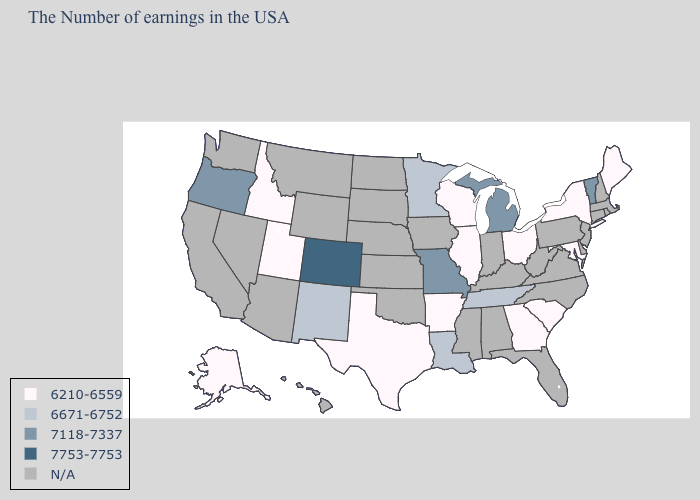Name the states that have a value in the range 7118-7337?
Quick response, please. Vermont, Michigan, Missouri, Oregon. What is the value of South Carolina?
Write a very short answer. 6210-6559. Name the states that have a value in the range 6210-6559?
Write a very short answer. Maine, New York, Maryland, South Carolina, Ohio, Georgia, Wisconsin, Illinois, Arkansas, Texas, Utah, Idaho, Alaska. What is the lowest value in the Northeast?
Quick response, please. 6210-6559. What is the highest value in the South ?
Be succinct. 6671-6752. Does the first symbol in the legend represent the smallest category?
Answer briefly. Yes. Is the legend a continuous bar?
Concise answer only. No. What is the lowest value in the MidWest?
Give a very brief answer. 6210-6559. Among the states that border Nebraska , does Missouri have the highest value?
Concise answer only. No. Does Michigan have the lowest value in the USA?
Write a very short answer. No. Does Colorado have the highest value in the West?
Give a very brief answer. Yes. What is the value of Rhode Island?
Keep it brief. N/A. Does Louisiana have the lowest value in the South?
Give a very brief answer. No. What is the value of South Carolina?
Quick response, please. 6210-6559. 